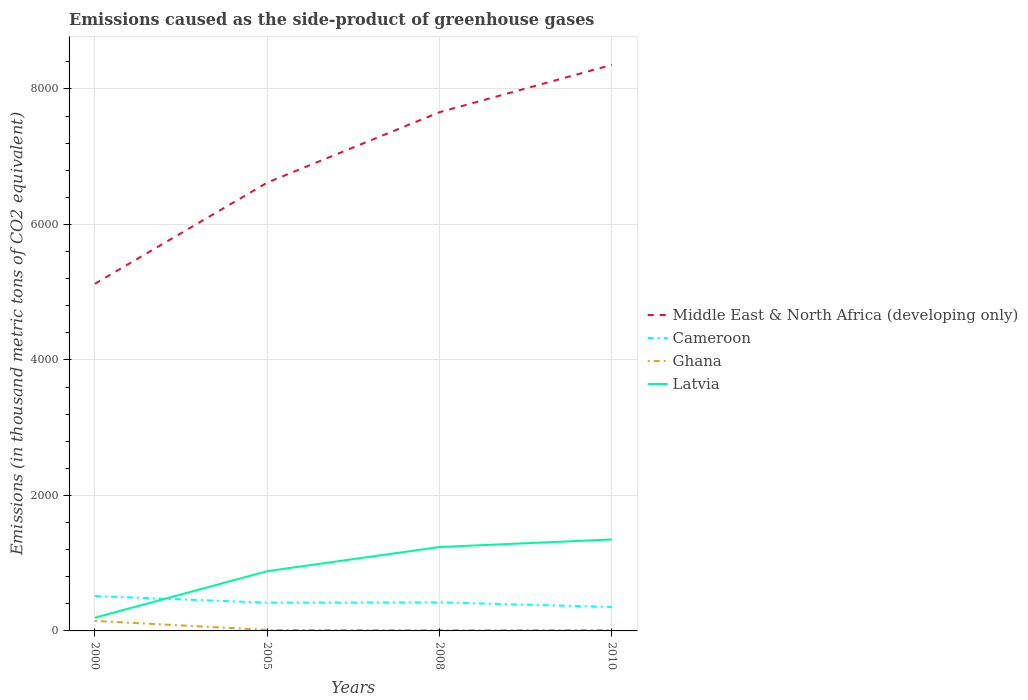Across all years, what is the maximum emissions caused as the side-product of greenhouse gases in Ghana?
Give a very brief answer. 11.2. In which year was the emissions caused as the side-product of greenhouse gases in Latvia maximum?
Provide a short and direct response. 2000. What is the difference between the highest and the second highest emissions caused as the side-product of greenhouse gases in Latvia?
Offer a very short reply. 1154.3. How many lines are there?
Your response must be concise. 4. What is the difference between two consecutive major ticks on the Y-axis?
Your answer should be compact. 2000. Does the graph contain any zero values?
Your response must be concise. No. Does the graph contain grids?
Make the answer very short. Yes. How many legend labels are there?
Your answer should be very brief. 4. How are the legend labels stacked?
Make the answer very short. Vertical. What is the title of the graph?
Make the answer very short. Emissions caused as the side-product of greenhouse gases. What is the label or title of the Y-axis?
Provide a short and direct response. Emissions (in thousand metric tons of CO2 equivalent). What is the Emissions (in thousand metric tons of CO2 equivalent) in Middle East & North Africa (developing only) in 2000?
Your response must be concise. 5124.9. What is the Emissions (in thousand metric tons of CO2 equivalent) of Cameroon in 2000?
Your answer should be very brief. 514.7. What is the Emissions (in thousand metric tons of CO2 equivalent) of Ghana in 2000?
Ensure brevity in your answer.  148. What is the Emissions (in thousand metric tons of CO2 equivalent) of Latvia in 2000?
Offer a terse response. 195.7. What is the Emissions (in thousand metric tons of CO2 equivalent) of Middle East & North Africa (developing only) in 2005?
Your answer should be very brief. 6617.8. What is the Emissions (in thousand metric tons of CO2 equivalent) in Cameroon in 2005?
Provide a short and direct response. 417.5. What is the Emissions (in thousand metric tons of CO2 equivalent) of Latvia in 2005?
Provide a short and direct response. 882.1. What is the Emissions (in thousand metric tons of CO2 equivalent) of Middle East & North Africa (developing only) in 2008?
Offer a terse response. 7657.2. What is the Emissions (in thousand metric tons of CO2 equivalent) in Cameroon in 2008?
Keep it short and to the point. 422.1. What is the Emissions (in thousand metric tons of CO2 equivalent) of Ghana in 2008?
Give a very brief answer. 11.2. What is the Emissions (in thousand metric tons of CO2 equivalent) of Latvia in 2008?
Provide a succinct answer. 1238.6. What is the Emissions (in thousand metric tons of CO2 equivalent) in Middle East & North Africa (developing only) in 2010?
Offer a very short reply. 8356. What is the Emissions (in thousand metric tons of CO2 equivalent) of Cameroon in 2010?
Ensure brevity in your answer.  353. What is the Emissions (in thousand metric tons of CO2 equivalent) of Latvia in 2010?
Your response must be concise. 1350. Across all years, what is the maximum Emissions (in thousand metric tons of CO2 equivalent) of Middle East & North Africa (developing only)?
Your answer should be compact. 8356. Across all years, what is the maximum Emissions (in thousand metric tons of CO2 equivalent) of Cameroon?
Make the answer very short. 514.7. Across all years, what is the maximum Emissions (in thousand metric tons of CO2 equivalent) of Ghana?
Make the answer very short. 148. Across all years, what is the maximum Emissions (in thousand metric tons of CO2 equivalent) in Latvia?
Your answer should be compact. 1350. Across all years, what is the minimum Emissions (in thousand metric tons of CO2 equivalent) of Middle East & North Africa (developing only)?
Give a very brief answer. 5124.9. Across all years, what is the minimum Emissions (in thousand metric tons of CO2 equivalent) of Cameroon?
Provide a succinct answer. 353. Across all years, what is the minimum Emissions (in thousand metric tons of CO2 equivalent) in Latvia?
Give a very brief answer. 195.7. What is the total Emissions (in thousand metric tons of CO2 equivalent) of Middle East & North Africa (developing only) in the graph?
Offer a very short reply. 2.78e+04. What is the total Emissions (in thousand metric tons of CO2 equivalent) in Cameroon in the graph?
Offer a very short reply. 1707.3. What is the total Emissions (in thousand metric tons of CO2 equivalent) of Ghana in the graph?
Provide a succinct answer. 186.9. What is the total Emissions (in thousand metric tons of CO2 equivalent) in Latvia in the graph?
Your response must be concise. 3666.4. What is the difference between the Emissions (in thousand metric tons of CO2 equivalent) of Middle East & North Africa (developing only) in 2000 and that in 2005?
Offer a terse response. -1492.9. What is the difference between the Emissions (in thousand metric tons of CO2 equivalent) of Cameroon in 2000 and that in 2005?
Provide a succinct answer. 97.2. What is the difference between the Emissions (in thousand metric tons of CO2 equivalent) in Ghana in 2000 and that in 2005?
Your answer should be compact. 133.3. What is the difference between the Emissions (in thousand metric tons of CO2 equivalent) in Latvia in 2000 and that in 2005?
Keep it short and to the point. -686.4. What is the difference between the Emissions (in thousand metric tons of CO2 equivalent) of Middle East & North Africa (developing only) in 2000 and that in 2008?
Ensure brevity in your answer.  -2532.3. What is the difference between the Emissions (in thousand metric tons of CO2 equivalent) in Cameroon in 2000 and that in 2008?
Give a very brief answer. 92.6. What is the difference between the Emissions (in thousand metric tons of CO2 equivalent) in Ghana in 2000 and that in 2008?
Your answer should be compact. 136.8. What is the difference between the Emissions (in thousand metric tons of CO2 equivalent) of Latvia in 2000 and that in 2008?
Provide a succinct answer. -1042.9. What is the difference between the Emissions (in thousand metric tons of CO2 equivalent) of Middle East & North Africa (developing only) in 2000 and that in 2010?
Keep it short and to the point. -3231.1. What is the difference between the Emissions (in thousand metric tons of CO2 equivalent) in Cameroon in 2000 and that in 2010?
Keep it short and to the point. 161.7. What is the difference between the Emissions (in thousand metric tons of CO2 equivalent) of Ghana in 2000 and that in 2010?
Provide a succinct answer. 135. What is the difference between the Emissions (in thousand metric tons of CO2 equivalent) of Latvia in 2000 and that in 2010?
Your response must be concise. -1154.3. What is the difference between the Emissions (in thousand metric tons of CO2 equivalent) in Middle East & North Africa (developing only) in 2005 and that in 2008?
Give a very brief answer. -1039.4. What is the difference between the Emissions (in thousand metric tons of CO2 equivalent) of Cameroon in 2005 and that in 2008?
Your answer should be compact. -4.6. What is the difference between the Emissions (in thousand metric tons of CO2 equivalent) in Latvia in 2005 and that in 2008?
Provide a succinct answer. -356.5. What is the difference between the Emissions (in thousand metric tons of CO2 equivalent) in Middle East & North Africa (developing only) in 2005 and that in 2010?
Provide a succinct answer. -1738.2. What is the difference between the Emissions (in thousand metric tons of CO2 equivalent) of Cameroon in 2005 and that in 2010?
Your answer should be very brief. 64.5. What is the difference between the Emissions (in thousand metric tons of CO2 equivalent) in Ghana in 2005 and that in 2010?
Provide a succinct answer. 1.7. What is the difference between the Emissions (in thousand metric tons of CO2 equivalent) of Latvia in 2005 and that in 2010?
Your response must be concise. -467.9. What is the difference between the Emissions (in thousand metric tons of CO2 equivalent) of Middle East & North Africa (developing only) in 2008 and that in 2010?
Provide a short and direct response. -698.8. What is the difference between the Emissions (in thousand metric tons of CO2 equivalent) of Cameroon in 2008 and that in 2010?
Your answer should be compact. 69.1. What is the difference between the Emissions (in thousand metric tons of CO2 equivalent) of Latvia in 2008 and that in 2010?
Your response must be concise. -111.4. What is the difference between the Emissions (in thousand metric tons of CO2 equivalent) in Middle East & North Africa (developing only) in 2000 and the Emissions (in thousand metric tons of CO2 equivalent) in Cameroon in 2005?
Offer a very short reply. 4707.4. What is the difference between the Emissions (in thousand metric tons of CO2 equivalent) of Middle East & North Africa (developing only) in 2000 and the Emissions (in thousand metric tons of CO2 equivalent) of Ghana in 2005?
Your answer should be compact. 5110.2. What is the difference between the Emissions (in thousand metric tons of CO2 equivalent) in Middle East & North Africa (developing only) in 2000 and the Emissions (in thousand metric tons of CO2 equivalent) in Latvia in 2005?
Offer a very short reply. 4242.8. What is the difference between the Emissions (in thousand metric tons of CO2 equivalent) in Cameroon in 2000 and the Emissions (in thousand metric tons of CO2 equivalent) in Ghana in 2005?
Offer a very short reply. 500. What is the difference between the Emissions (in thousand metric tons of CO2 equivalent) of Cameroon in 2000 and the Emissions (in thousand metric tons of CO2 equivalent) of Latvia in 2005?
Ensure brevity in your answer.  -367.4. What is the difference between the Emissions (in thousand metric tons of CO2 equivalent) in Ghana in 2000 and the Emissions (in thousand metric tons of CO2 equivalent) in Latvia in 2005?
Your answer should be compact. -734.1. What is the difference between the Emissions (in thousand metric tons of CO2 equivalent) of Middle East & North Africa (developing only) in 2000 and the Emissions (in thousand metric tons of CO2 equivalent) of Cameroon in 2008?
Your answer should be compact. 4702.8. What is the difference between the Emissions (in thousand metric tons of CO2 equivalent) in Middle East & North Africa (developing only) in 2000 and the Emissions (in thousand metric tons of CO2 equivalent) in Ghana in 2008?
Your response must be concise. 5113.7. What is the difference between the Emissions (in thousand metric tons of CO2 equivalent) in Middle East & North Africa (developing only) in 2000 and the Emissions (in thousand metric tons of CO2 equivalent) in Latvia in 2008?
Offer a very short reply. 3886.3. What is the difference between the Emissions (in thousand metric tons of CO2 equivalent) in Cameroon in 2000 and the Emissions (in thousand metric tons of CO2 equivalent) in Ghana in 2008?
Offer a terse response. 503.5. What is the difference between the Emissions (in thousand metric tons of CO2 equivalent) of Cameroon in 2000 and the Emissions (in thousand metric tons of CO2 equivalent) of Latvia in 2008?
Provide a succinct answer. -723.9. What is the difference between the Emissions (in thousand metric tons of CO2 equivalent) in Ghana in 2000 and the Emissions (in thousand metric tons of CO2 equivalent) in Latvia in 2008?
Your answer should be very brief. -1090.6. What is the difference between the Emissions (in thousand metric tons of CO2 equivalent) in Middle East & North Africa (developing only) in 2000 and the Emissions (in thousand metric tons of CO2 equivalent) in Cameroon in 2010?
Your answer should be compact. 4771.9. What is the difference between the Emissions (in thousand metric tons of CO2 equivalent) in Middle East & North Africa (developing only) in 2000 and the Emissions (in thousand metric tons of CO2 equivalent) in Ghana in 2010?
Keep it short and to the point. 5111.9. What is the difference between the Emissions (in thousand metric tons of CO2 equivalent) of Middle East & North Africa (developing only) in 2000 and the Emissions (in thousand metric tons of CO2 equivalent) of Latvia in 2010?
Give a very brief answer. 3774.9. What is the difference between the Emissions (in thousand metric tons of CO2 equivalent) in Cameroon in 2000 and the Emissions (in thousand metric tons of CO2 equivalent) in Ghana in 2010?
Give a very brief answer. 501.7. What is the difference between the Emissions (in thousand metric tons of CO2 equivalent) of Cameroon in 2000 and the Emissions (in thousand metric tons of CO2 equivalent) of Latvia in 2010?
Make the answer very short. -835.3. What is the difference between the Emissions (in thousand metric tons of CO2 equivalent) of Ghana in 2000 and the Emissions (in thousand metric tons of CO2 equivalent) of Latvia in 2010?
Make the answer very short. -1202. What is the difference between the Emissions (in thousand metric tons of CO2 equivalent) in Middle East & North Africa (developing only) in 2005 and the Emissions (in thousand metric tons of CO2 equivalent) in Cameroon in 2008?
Your answer should be compact. 6195.7. What is the difference between the Emissions (in thousand metric tons of CO2 equivalent) of Middle East & North Africa (developing only) in 2005 and the Emissions (in thousand metric tons of CO2 equivalent) of Ghana in 2008?
Provide a short and direct response. 6606.6. What is the difference between the Emissions (in thousand metric tons of CO2 equivalent) in Middle East & North Africa (developing only) in 2005 and the Emissions (in thousand metric tons of CO2 equivalent) in Latvia in 2008?
Offer a very short reply. 5379.2. What is the difference between the Emissions (in thousand metric tons of CO2 equivalent) of Cameroon in 2005 and the Emissions (in thousand metric tons of CO2 equivalent) of Ghana in 2008?
Provide a succinct answer. 406.3. What is the difference between the Emissions (in thousand metric tons of CO2 equivalent) in Cameroon in 2005 and the Emissions (in thousand metric tons of CO2 equivalent) in Latvia in 2008?
Provide a succinct answer. -821.1. What is the difference between the Emissions (in thousand metric tons of CO2 equivalent) in Ghana in 2005 and the Emissions (in thousand metric tons of CO2 equivalent) in Latvia in 2008?
Provide a succinct answer. -1223.9. What is the difference between the Emissions (in thousand metric tons of CO2 equivalent) in Middle East & North Africa (developing only) in 2005 and the Emissions (in thousand metric tons of CO2 equivalent) in Cameroon in 2010?
Ensure brevity in your answer.  6264.8. What is the difference between the Emissions (in thousand metric tons of CO2 equivalent) in Middle East & North Africa (developing only) in 2005 and the Emissions (in thousand metric tons of CO2 equivalent) in Ghana in 2010?
Offer a very short reply. 6604.8. What is the difference between the Emissions (in thousand metric tons of CO2 equivalent) of Middle East & North Africa (developing only) in 2005 and the Emissions (in thousand metric tons of CO2 equivalent) of Latvia in 2010?
Offer a terse response. 5267.8. What is the difference between the Emissions (in thousand metric tons of CO2 equivalent) in Cameroon in 2005 and the Emissions (in thousand metric tons of CO2 equivalent) in Ghana in 2010?
Give a very brief answer. 404.5. What is the difference between the Emissions (in thousand metric tons of CO2 equivalent) in Cameroon in 2005 and the Emissions (in thousand metric tons of CO2 equivalent) in Latvia in 2010?
Your answer should be very brief. -932.5. What is the difference between the Emissions (in thousand metric tons of CO2 equivalent) of Ghana in 2005 and the Emissions (in thousand metric tons of CO2 equivalent) of Latvia in 2010?
Provide a succinct answer. -1335.3. What is the difference between the Emissions (in thousand metric tons of CO2 equivalent) of Middle East & North Africa (developing only) in 2008 and the Emissions (in thousand metric tons of CO2 equivalent) of Cameroon in 2010?
Give a very brief answer. 7304.2. What is the difference between the Emissions (in thousand metric tons of CO2 equivalent) of Middle East & North Africa (developing only) in 2008 and the Emissions (in thousand metric tons of CO2 equivalent) of Ghana in 2010?
Provide a succinct answer. 7644.2. What is the difference between the Emissions (in thousand metric tons of CO2 equivalent) of Middle East & North Africa (developing only) in 2008 and the Emissions (in thousand metric tons of CO2 equivalent) of Latvia in 2010?
Provide a short and direct response. 6307.2. What is the difference between the Emissions (in thousand metric tons of CO2 equivalent) in Cameroon in 2008 and the Emissions (in thousand metric tons of CO2 equivalent) in Ghana in 2010?
Your answer should be very brief. 409.1. What is the difference between the Emissions (in thousand metric tons of CO2 equivalent) in Cameroon in 2008 and the Emissions (in thousand metric tons of CO2 equivalent) in Latvia in 2010?
Offer a very short reply. -927.9. What is the difference between the Emissions (in thousand metric tons of CO2 equivalent) of Ghana in 2008 and the Emissions (in thousand metric tons of CO2 equivalent) of Latvia in 2010?
Your answer should be very brief. -1338.8. What is the average Emissions (in thousand metric tons of CO2 equivalent) in Middle East & North Africa (developing only) per year?
Make the answer very short. 6938.98. What is the average Emissions (in thousand metric tons of CO2 equivalent) of Cameroon per year?
Ensure brevity in your answer.  426.82. What is the average Emissions (in thousand metric tons of CO2 equivalent) of Ghana per year?
Give a very brief answer. 46.73. What is the average Emissions (in thousand metric tons of CO2 equivalent) of Latvia per year?
Your answer should be very brief. 916.6. In the year 2000, what is the difference between the Emissions (in thousand metric tons of CO2 equivalent) in Middle East & North Africa (developing only) and Emissions (in thousand metric tons of CO2 equivalent) in Cameroon?
Make the answer very short. 4610.2. In the year 2000, what is the difference between the Emissions (in thousand metric tons of CO2 equivalent) in Middle East & North Africa (developing only) and Emissions (in thousand metric tons of CO2 equivalent) in Ghana?
Your response must be concise. 4976.9. In the year 2000, what is the difference between the Emissions (in thousand metric tons of CO2 equivalent) in Middle East & North Africa (developing only) and Emissions (in thousand metric tons of CO2 equivalent) in Latvia?
Provide a short and direct response. 4929.2. In the year 2000, what is the difference between the Emissions (in thousand metric tons of CO2 equivalent) in Cameroon and Emissions (in thousand metric tons of CO2 equivalent) in Ghana?
Offer a very short reply. 366.7. In the year 2000, what is the difference between the Emissions (in thousand metric tons of CO2 equivalent) in Cameroon and Emissions (in thousand metric tons of CO2 equivalent) in Latvia?
Your answer should be compact. 319. In the year 2000, what is the difference between the Emissions (in thousand metric tons of CO2 equivalent) in Ghana and Emissions (in thousand metric tons of CO2 equivalent) in Latvia?
Give a very brief answer. -47.7. In the year 2005, what is the difference between the Emissions (in thousand metric tons of CO2 equivalent) of Middle East & North Africa (developing only) and Emissions (in thousand metric tons of CO2 equivalent) of Cameroon?
Offer a very short reply. 6200.3. In the year 2005, what is the difference between the Emissions (in thousand metric tons of CO2 equivalent) in Middle East & North Africa (developing only) and Emissions (in thousand metric tons of CO2 equivalent) in Ghana?
Your answer should be compact. 6603.1. In the year 2005, what is the difference between the Emissions (in thousand metric tons of CO2 equivalent) of Middle East & North Africa (developing only) and Emissions (in thousand metric tons of CO2 equivalent) of Latvia?
Your answer should be very brief. 5735.7. In the year 2005, what is the difference between the Emissions (in thousand metric tons of CO2 equivalent) in Cameroon and Emissions (in thousand metric tons of CO2 equivalent) in Ghana?
Give a very brief answer. 402.8. In the year 2005, what is the difference between the Emissions (in thousand metric tons of CO2 equivalent) of Cameroon and Emissions (in thousand metric tons of CO2 equivalent) of Latvia?
Your answer should be compact. -464.6. In the year 2005, what is the difference between the Emissions (in thousand metric tons of CO2 equivalent) of Ghana and Emissions (in thousand metric tons of CO2 equivalent) of Latvia?
Keep it short and to the point. -867.4. In the year 2008, what is the difference between the Emissions (in thousand metric tons of CO2 equivalent) of Middle East & North Africa (developing only) and Emissions (in thousand metric tons of CO2 equivalent) of Cameroon?
Offer a terse response. 7235.1. In the year 2008, what is the difference between the Emissions (in thousand metric tons of CO2 equivalent) of Middle East & North Africa (developing only) and Emissions (in thousand metric tons of CO2 equivalent) of Ghana?
Give a very brief answer. 7646. In the year 2008, what is the difference between the Emissions (in thousand metric tons of CO2 equivalent) of Middle East & North Africa (developing only) and Emissions (in thousand metric tons of CO2 equivalent) of Latvia?
Offer a terse response. 6418.6. In the year 2008, what is the difference between the Emissions (in thousand metric tons of CO2 equivalent) in Cameroon and Emissions (in thousand metric tons of CO2 equivalent) in Ghana?
Keep it short and to the point. 410.9. In the year 2008, what is the difference between the Emissions (in thousand metric tons of CO2 equivalent) of Cameroon and Emissions (in thousand metric tons of CO2 equivalent) of Latvia?
Your response must be concise. -816.5. In the year 2008, what is the difference between the Emissions (in thousand metric tons of CO2 equivalent) in Ghana and Emissions (in thousand metric tons of CO2 equivalent) in Latvia?
Provide a short and direct response. -1227.4. In the year 2010, what is the difference between the Emissions (in thousand metric tons of CO2 equivalent) of Middle East & North Africa (developing only) and Emissions (in thousand metric tons of CO2 equivalent) of Cameroon?
Your response must be concise. 8003. In the year 2010, what is the difference between the Emissions (in thousand metric tons of CO2 equivalent) in Middle East & North Africa (developing only) and Emissions (in thousand metric tons of CO2 equivalent) in Ghana?
Offer a very short reply. 8343. In the year 2010, what is the difference between the Emissions (in thousand metric tons of CO2 equivalent) in Middle East & North Africa (developing only) and Emissions (in thousand metric tons of CO2 equivalent) in Latvia?
Provide a succinct answer. 7006. In the year 2010, what is the difference between the Emissions (in thousand metric tons of CO2 equivalent) in Cameroon and Emissions (in thousand metric tons of CO2 equivalent) in Ghana?
Make the answer very short. 340. In the year 2010, what is the difference between the Emissions (in thousand metric tons of CO2 equivalent) of Cameroon and Emissions (in thousand metric tons of CO2 equivalent) of Latvia?
Give a very brief answer. -997. In the year 2010, what is the difference between the Emissions (in thousand metric tons of CO2 equivalent) of Ghana and Emissions (in thousand metric tons of CO2 equivalent) of Latvia?
Provide a short and direct response. -1337. What is the ratio of the Emissions (in thousand metric tons of CO2 equivalent) in Middle East & North Africa (developing only) in 2000 to that in 2005?
Give a very brief answer. 0.77. What is the ratio of the Emissions (in thousand metric tons of CO2 equivalent) in Cameroon in 2000 to that in 2005?
Keep it short and to the point. 1.23. What is the ratio of the Emissions (in thousand metric tons of CO2 equivalent) of Ghana in 2000 to that in 2005?
Make the answer very short. 10.07. What is the ratio of the Emissions (in thousand metric tons of CO2 equivalent) in Latvia in 2000 to that in 2005?
Your answer should be very brief. 0.22. What is the ratio of the Emissions (in thousand metric tons of CO2 equivalent) in Middle East & North Africa (developing only) in 2000 to that in 2008?
Provide a succinct answer. 0.67. What is the ratio of the Emissions (in thousand metric tons of CO2 equivalent) in Cameroon in 2000 to that in 2008?
Offer a very short reply. 1.22. What is the ratio of the Emissions (in thousand metric tons of CO2 equivalent) in Ghana in 2000 to that in 2008?
Keep it short and to the point. 13.21. What is the ratio of the Emissions (in thousand metric tons of CO2 equivalent) of Latvia in 2000 to that in 2008?
Ensure brevity in your answer.  0.16. What is the ratio of the Emissions (in thousand metric tons of CO2 equivalent) in Middle East & North Africa (developing only) in 2000 to that in 2010?
Provide a short and direct response. 0.61. What is the ratio of the Emissions (in thousand metric tons of CO2 equivalent) of Cameroon in 2000 to that in 2010?
Ensure brevity in your answer.  1.46. What is the ratio of the Emissions (in thousand metric tons of CO2 equivalent) of Ghana in 2000 to that in 2010?
Provide a short and direct response. 11.38. What is the ratio of the Emissions (in thousand metric tons of CO2 equivalent) in Latvia in 2000 to that in 2010?
Offer a terse response. 0.14. What is the ratio of the Emissions (in thousand metric tons of CO2 equivalent) in Middle East & North Africa (developing only) in 2005 to that in 2008?
Your response must be concise. 0.86. What is the ratio of the Emissions (in thousand metric tons of CO2 equivalent) in Cameroon in 2005 to that in 2008?
Give a very brief answer. 0.99. What is the ratio of the Emissions (in thousand metric tons of CO2 equivalent) of Ghana in 2005 to that in 2008?
Ensure brevity in your answer.  1.31. What is the ratio of the Emissions (in thousand metric tons of CO2 equivalent) in Latvia in 2005 to that in 2008?
Your response must be concise. 0.71. What is the ratio of the Emissions (in thousand metric tons of CO2 equivalent) in Middle East & North Africa (developing only) in 2005 to that in 2010?
Your answer should be compact. 0.79. What is the ratio of the Emissions (in thousand metric tons of CO2 equivalent) of Cameroon in 2005 to that in 2010?
Provide a succinct answer. 1.18. What is the ratio of the Emissions (in thousand metric tons of CO2 equivalent) of Ghana in 2005 to that in 2010?
Provide a short and direct response. 1.13. What is the ratio of the Emissions (in thousand metric tons of CO2 equivalent) in Latvia in 2005 to that in 2010?
Provide a short and direct response. 0.65. What is the ratio of the Emissions (in thousand metric tons of CO2 equivalent) of Middle East & North Africa (developing only) in 2008 to that in 2010?
Make the answer very short. 0.92. What is the ratio of the Emissions (in thousand metric tons of CO2 equivalent) in Cameroon in 2008 to that in 2010?
Keep it short and to the point. 1.2. What is the ratio of the Emissions (in thousand metric tons of CO2 equivalent) of Ghana in 2008 to that in 2010?
Provide a succinct answer. 0.86. What is the ratio of the Emissions (in thousand metric tons of CO2 equivalent) in Latvia in 2008 to that in 2010?
Your answer should be compact. 0.92. What is the difference between the highest and the second highest Emissions (in thousand metric tons of CO2 equivalent) in Middle East & North Africa (developing only)?
Provide a short and direct response. 698.8. What is the difference between the highest and the second highest Emissions (in thousand metric tons of CO2 equivalent) of Cameroon?
Keep it short and to the point. 92.6. What is the difference between the highest and the second highest Emissions (in thousand metric tons of CO2 equivalent) of Ghana?
Give a very brief answer. 133.3. What is the difference between the highest and the second highest Emissions (in thousand metric tons of CO2 equivalent) in Latvia?
Give a very brief answer. 111.4. What is the difference between the highest and the lowest Emissions (in thousand metric tons of CO2 equivalent) of Middle East & North Africa (developing only)?
Provide a short and direct response. 3231.1. What is the difference between the highest and the lowest Emissions (in thousand metric tons of CO2 equivalent) in Cameroon?
Your answer should be compact. 161.7. What is the difference between the highest and the lowest Emissions (in thousand metric tons of CO2 equivalent) in Ghana?
Ensure brevity in your answer.  136.8. What is the difference between the highest and the lowest Emissions (in thousand metric tons of CO2 equivalent) in Latvia?
Give a very brief answer. 1154.3. 